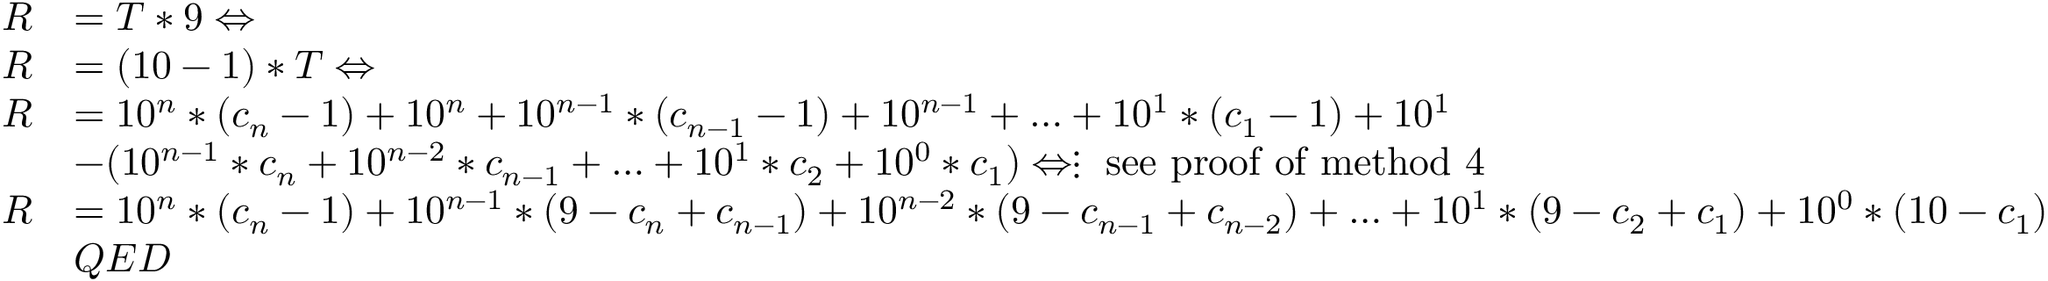<formula> <loc_0><loc_0><loc_500><loc_500>{ \begin{array} { r l } { R } & { = T * 9 \Leftrightarrow } \\ { R } & { = ( 1 0 - 1 ) * T \Leftrightarrow } \\ { R } & { = 1 0 ^ { n } * ( c _ { n } - 1 ) + 1 0 ^ { n } + 1 0 ^ { n - 1 } * ( c _ { n - 1 } - 1 ) + 1 0 ^ { n - 1 } + \dots + 1 0 ^ { 1 } * ( c _ { 1 } - 1 ) + 1 0 ^ { 1 } } \\ & { - ( 1 0 ^ { n - 1 } * c _ { n } + 1 0 ^ { n - 2 } * c _ { n - 1 } + \dots + 1 0 ^ { 1 } * c _ { 2 } + 1 0 ^ { 0 } * c _ { 1 } ) \Leftrightarrow \vdots { s e e p r o o f o f m e t h o d 4 } } \\ { R } & { = 1 0 ^ { n } * ( c _ { n } - 1 ) + 1 0 ^ { n - 1 } * ( 9 - c _ { n } + c _ { n - 1 } ) + 1 0 ^ { n - 2 } * ( 9 - c _ { n - 1 } + c _ { n - 2 } ) + \dots + 1 0 ^ { 1 } * ( 9 - c _ { 2 } + c _ { 1 } ) + 1 0 ^ { 0 } * ( 1 0 - c _ { 1 } ) } \\ & { Q E D } \end{array} }</formula> 